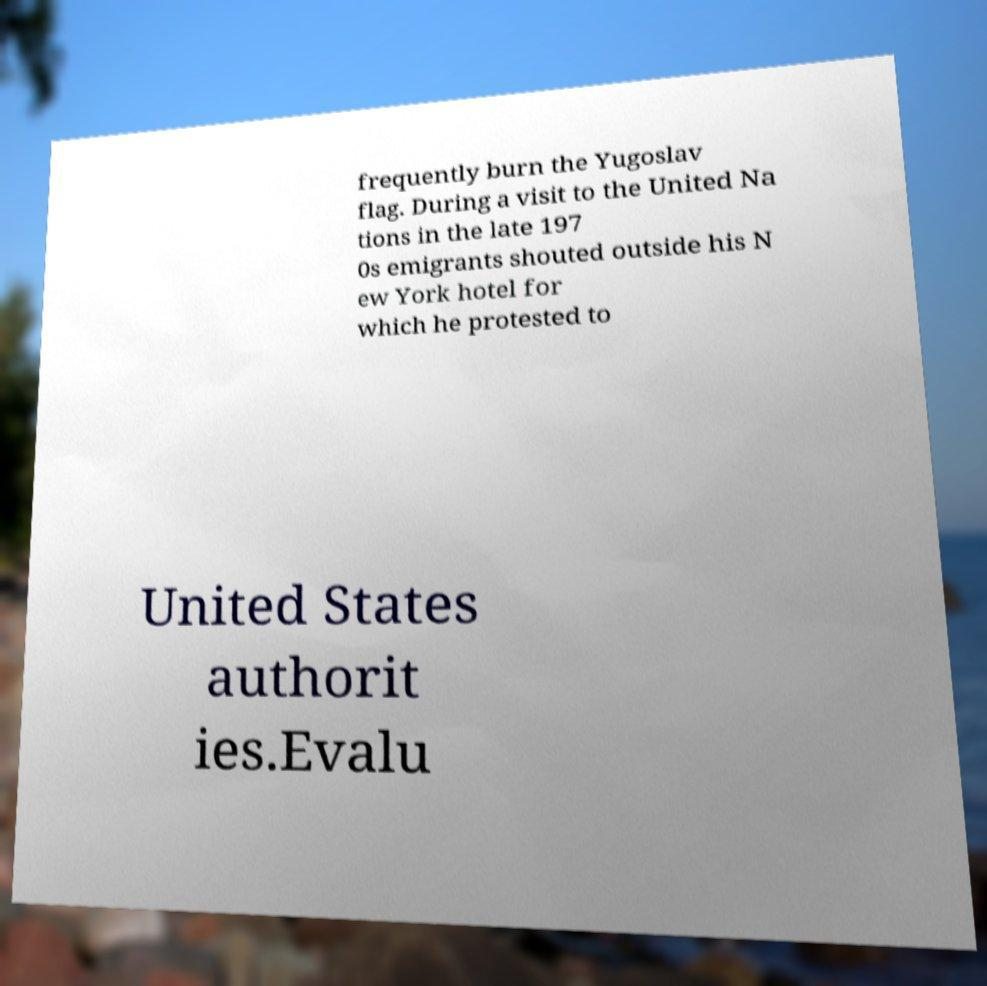There's text embedded in this image that I need extracted. Can you transcribe it verbatim? frequently burn the Yugoslav flag. During a visit to the United Na tions in the late 197 0s emigrants shouted outside his N ew York hotel for which he protested to United States authorit ies.Evalu 